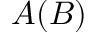<formula> <loc_0><loc_0><loc_500><loc_500>A ( B )</formula> 